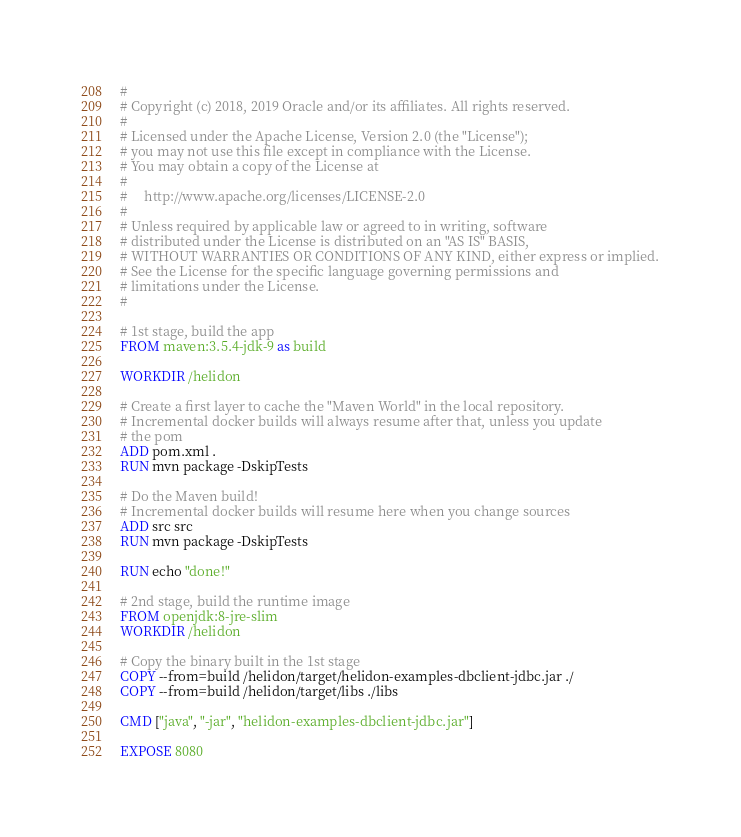<code> <loc_0><loc_0><loc_500><loc_500><_Dockerfile_>#
# Copyright (c) 2018, 2019 Oracle and/or its affiliates. All rights reserved.
#
# Licensed under the Apache License, Version 2.0 (the "License");
# you may not use this file except in compliance with the License.
# You may obtain a copy of the License at
#
#     http://www.apache.org/licenses/LICENSE-2.0
#
# Unless required by applicable law or agreed to in writing, software
# distributed under the License is distributed on an "AS IS" BASIS,
# WITHOUT WARRANTIES OR CONDITIONS OF ANY KIND, either express or implied.
# See the License for the specific language governing permissions and
# limitations under the License.
#

# 1st stage, build the app
FROM maven:3.5.4-jdk-9 as build

WORKDIR /helidon

# Create a first layer to cache the "Maven World" in the local repository.
# Incremental docker builds will always resume after that, unless you update
# the pom
ADD pom.xml .
RUN mvn package -DskipTests

# Do the Maven build!
# Incremental docker builds will resume here when you change sources
ADD src src
RUN mvn package -DskipTests

RUN echo "done!"

# 2nd stage, build the runtime image
FROM openjdk:8-jre-slim
WORKDIR /helidon

# Copy the binary built in the 1st stage
COPY --from=build /helidon/target/helidon-examples-dbclient-jdbc.jar ./
COPY --from=build /helidon/target/libs ./libs

CMD ["java", "-jar", "helidon-examples-dbclient-jdbc.jar"]

EXPOSE 8080</code> 